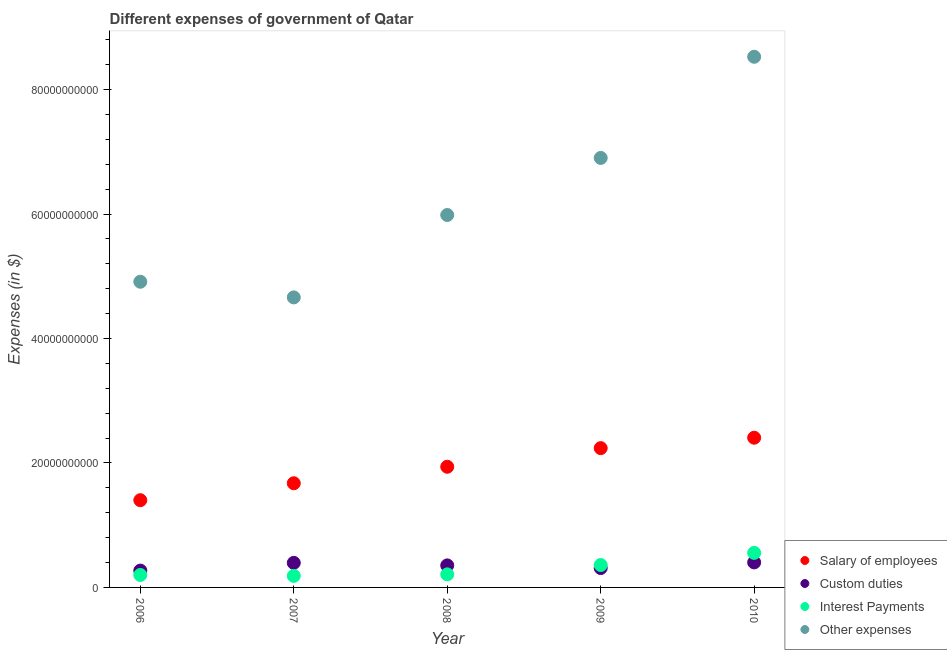How many different coloured dotlines are there?
Make the answer very short. 4. Is the number of dotlines equal to the number of legend labels?
Your answer should be very brief. Yes. What is the amount spent on salary of employees in 2006?
Your answer should be compact. 1.40e+1. Across all years, what is the maximum amount spent on other expenses?
Ensure brevity in your answer.  8.53e+1. Across all years, what is the minimum amount spent on custom duties?
Make the answer very short. 2.70e+09. What is the total amount spent on custom duties in the graph?
Give a very brief answer. 1.73e+1. What is the difference between the amount spent on interest payments in 2006 and that in 2008?
Your response must be concise. -9.39e+07. What is the difference between the amount spent on interest payments in 2010 and the amount spent on custom duties in 2008?
Your answer should be compact. 2.01e+09. What is the average amount spent on custom duties per year?
Give a very brief answer. 3.46e+09. In the year 2007, what is the difference between the amount spent on other expenses and amount spent on salary of employees?
Provide a short and direct response. 2.99e+1. What is the ratio of the amount spent on custom duties in 2006 to that in 2010?
Provide a short and direct response. 0.67. Is the amount spent on other expenses in 2006 less than that in 2009?
Ensure brevity in your answer.  Yes. Is the difference between the amount spent on salary of employees in 2007 and 2010 greater than the difference between the amount spent on interest payments in 2007 and 2010?
Provide a succinct answer. No. What is the difference between the highest and the second highest amount spent on other expenses?
Provide a succinct answer. 1.63e+1. What is the difference between the highest and the lowest amount spent on interest payments?
Offer a terse response. 3.69e+09. In how many years, is the amount spent on other expenses greater than the average amount spent on other expenses taken over all years?
Your answer should be very brief. 2. Is the sum of the amount spent on interest payments in 2008 and 2010 greater than the maximum amount spent on custom duties across all years?
Ensure brevity in your answer.  Yes. Is it the case that in every year, the sum of the amount spent on other expenses and amount spent on interest payments is greater than the sum of amount spent on salary of employees and amount spent on custom duties?
Offer a very short reply. Yes. Does the amount spent on other expenses monotonically increase over the years?
Provide a succinct answer. No. Is the amount spent on salary of employees strictly greater than the amount spent on other expenses over the years?
Make the answer very short. No. Is the amount spent on salary of employees strictly less than the amount spent on interest payments over the years?
Make the answer very short. No. How many years are there in the graph?
Offer a very short reply. 5. What is the difference between two consecutive major ticks on the Y-axis?
Provide a short and direct response. 2.00e+1. Are the values on the major ticks of Y-axis written in scientific E-notation?
Make the answer very short. No. Does the graph contain any zero values?
Offer a terse response. No. Where does the legend appear in the graph?
Provide a short and direct response. Bottom right. How many legend labels are there?
Offer a very short reply. 4. What is the title of the graph?
Provide a succinct answer. Different expenses of government of Qatar. What is the label or title of the X-axis?
Make the answer very short. Year. What is the label or title of the Y-axis?
Keep it short and to the point. Expenses (in $). What is the Expenses (in $) of Salary of employees in 2006?
Your answer should be compact. 1.40e+1. What is the Expenses (in $) in Custom duties in 2006?
Make the answer very short. 2.70e+09. What is the Expenses (in $) in Interest Payments in 2006?
Your answer should be very brief. 2.01e+09. What is the Expenses (in $) of Other expenses in 2006?
Offer a very short reply. 4.91e+1. What is the Expenses (in $) of Salary of employees in 2007?
Ensure brevity in your answer.  1.67e+1. What is the Expenses (in $) of Custom duties in 2007?
Provide a short and direct response. 3.95e+09. What is the Expenses (in $) in Interest Payments in 2007?
Offer a very short reply. 1.86e+09. What is the Expenses (in $) in Other expenses in 2007?
Make the answer very short. 4.66e+1. What is the Expenses (in $) in Salary of employees in 2008?
Ensure brevity in your answer.  1.94e+1. What is the Expenses (in $) of Custom duties in 2008?
Provide a short and direct response. 3.54e+09. What is the Expenses (in $) of Interest Payments in 2008?
Your response must be concise. 2.10e+09. What is the Expenses (in $) of Other expenses in 2008?
Give a very brief answer. 5.98e+1. What is the Expenses (in $) in Salary of employees in 2009?
Your response must be concise. 2.24e+1. What is the Expenses (in $) in Custom duties in 2009?
Offer a very short reply. 3.11e+09. What is the Expenses (in $) of Interest Payments in 2009?
Provide a succinct answer. 3.60e+09. What is the Expenses (in $) of Other expenses in 2009?
Keep it short and to the point. 6.90e+1. What is the Expenses (in $) in Salary of employees in 2010?
Provide a succinct answer. 2.41e+1. What is the Expenses (in $) of Custom duties in 2010?
Ensure brevity in your answer.  4.02e+09. What is the Expenses (in $) in Interest Payments in 2010?
Offer a very short reply. 5.55e+09. What is the Expenses (in $) in Other expenses in 2010?
Give a very brief answer. 8.53e+1. Across all years, what is the maximum Expenses (in $) of Salary of employees?
Give a very brief answer. 2.41e+1. Across all years, what is the maximum Expenses (in $) in Custom duties?
Give a very brief answer. 4.02e+09. Across all years, what is the maximum Expenses (in $) in Interest Payments?
Provide a succinct answer. 5.55e+09. Across all years, what is the maximum Expenses (in $) in Other expenses?
Your answer should be very brief. 8.53e+1. Across all years, what is the minimum Expenses (in $) in Salary of employees?
Ensure brevity in your answer.  1.40e+1. Across all years, what is the minimum Expenses (in $) in Custom duties?
Your answer should be compact. 2.70e+09. Across all years, what is the minimum Expenses (in $) of Interest Payments?
Keep it short and to the point. 1.86e+09. Across all years, what is the minimum Expenses (in $) of Other expenses?
Provide a succinct answer. 4.66e+1. What is the total Expenses (in $) of Salary of employees in the graph?
Offer a terse response. 9.66e+1. What is the total Expenses (in $) in Custom duties in the graph?
Offer a very short reply. 1.73e+1. What is the total Expenses (in $) of Interest Payments in the graph?
Your answer should be compact. 1.51e+1. What is the total Expenses (in $) in Other expenses in the graph?
Give a very brief answer. 3.10e+11. What is the difference between the Expenses (in $) in Salary of employees in 2006 and that in 2007?
Offer a very short reply. -2.72e+09. What is the difference between the Expenses (in $) of Custom duties in 2006 and that in 2007?
Offer a very short reply. -1.24e+09. What is the difference between the Expenses (in $) of Interest Payments in 2006 and that in 2007?
Your answer should be very brief. 1.51e+08. What is the difference between the Expenses (in $) in Other expenses in 2006 and that in 2007?
Ensure brevity in your answer.  2.51e+09. What is the difference between the Expenses (in $) in Salary of employees in 2006 and that in 2008?
Make the answer very short. -5.37e+09. What is the difference between the Expenses (in $) of Custom duties in 2006 and that in 2008?
Keep it short and to the point. -8.38e+08. What is the difference between the Expenses (in $) of Interest Payments in 2006 and that in 2008?
Give a very brief answer. -9.39e+07. What is the difference between the Expenses (in $) of Other expenses in 2006 and that in 2008?
Your response must be concise. -1.07e+1. What is the difference between the Expenses (in $) of Salary of employees in 2006 and that in 2009?
Provide a succinct answer. -8.36e+09. What is the difference between the Expenses (in $) of Custom duties in 2006 and that in 2009?
Offer a very short reply. -4.11e+08. What is the difference between the Expenses (in $) in Interest Payments in 2006 and that in 2009?
Provide a succinct answer. -1.59e+09. What is the difference between the Expenses (in $) in Other expenses in 2006 and that in 2009?
Make the answer very short. -1.99e+1. What is the difference between the Expenses (in $) in Salary of employees in 2006 and that in 2010?
Keep it short and to the point. -1.00e+1. What is the difference between the Expenses (in $) of Custom duties in 2006 and that in 2010?
Provide a short and direct response. -1.32e+09. What is the difference between the Expenses (in $) in Interest Payments in 2006 and that in 2010?
Offer a terse response. -3.54e+09. What is the difference between the Expenses (in $) in Other expenses in 2006 and that in 2010?
Your answer should be very brief. -3.62e+1. What is the difference between the Expenses (in $) of Salary of employees in 2007 and that in 2008?
Your answer should be compact. -2.65e+09. What is the difference between the Expenses (in $) in Custom duties in 2007 and that in 2008?
Ensure brevity in your answer.  4.05e+08. What is the difference between the Expenses (in $) in Interest Payments in 2007 and that in 2008?
Your answer should be very brief. -2.45e+08. What is the difference between the Expenses (in $) in Other expenses in 2007 and that in 2008?
Make the answer very short. -1.32e+1. What is the difference between the Expenses (in $) in Salary of employees in 2007 and that in 2009?
Provide a short and direct response. -5.64e+09. What is the difference between the Expenses (in $) in Custom duties in 2007 and that in 2009?
Give a very brief answer. 8.32e+08. What is the difference between the Expenses (in $) in Interest Payments in 2007 and that in 2009?
Keep it short and to the point. -1.74e+09. What is the difference between the Expenses (in $) in Other expenses in 2007 and that in 2009?
Provide a succinct answer. -2.24e+1. What is the difference between the Expenses (in $) in Salary of employees in 2007 and that in 2010?
Give a very brief answer. -7.32e+09. What is the difference between the Expenses (in $) in Custom duties in 2007 and that in 2010?
Offer a terse response. -7.32e+07. What is the difference between the Expenses (in $) of Interest Payments in 2007 and that in 2010?
Provide a short and direct response. -3.69e+09. What is the difference between the Expenses (in $) in Other expenses in 2007 and that in 2010?
Give a very brief answer. -3.87e+1. What is the difference between the Expenses (in $) in Salary of employees in 2008 and that in 2009?
Give a very brief answer. -2.99e+09. What is the difference between the Expenses (in $) of Custom duties in 2008 and that in 2009?
Offer a terse response. 4.27e+08. What is the difference between the Expenses (in $) of Interest Payments in 2008 and that in 2009?
Ensure brevity in your answer.  -1.50e+09. What is the difference between the Expenses (in $) of Other expenses in 2008 and that in 2009?
Provide a short and direct response. -9.17e+09. What is the difference between the Expenses (in $) of Salary of employees in 2008 and that in 2010?
Give a very brief answer. -4.67e+09. What is the difference between the Expenses (in $) in Custom duties in 2008 and that in 2010?
Make the answer very short. -4.78e+08. What is the difference between the Expenses (in $) in Interest Payments in 2008 and that in 2010?
Your response must be concise. -3.45e+09. What is the difference between the Expenses (in $) of Other expenses in 2008 and that in 2010?
Offer a very short reply. -2.54e+1. What is the difference between the Expenses (in $) in Salary of employees in 2009 and that in 2010?
Your response must be concise. -1.67e+09. What is the difference between the Expenses (in $) in Custom duties in 2009 and that in 2010?
Offer a very short reply. -9.05e+08. What is the difference between the Expenses (in $) of Interest Payments in 2009 and that in 2010?
Provide a succinct answer. -1.95e+09. What is the difference between the Expenses (in $) of Other expenses in 2009 and that in 2010?
Ensure brevity in your answer.  -1.63e+1. What is the difference between the Expenses (in $) of Salary of employees in 2006 and the Expenses (in $) of Custom duties in 2007?
Offer a terse response. 1.01e+1. What is the difference between the Expenses (in $) of Salary of employees in 2006 and the Expenses (in $) of Interest Payments in 2007?
Your answer should be compact. 1.22e+1. What is the difference between the Expenses (in $) of Salary of employees in 2006 and the Expenses (in $) of Other expenses in 2007?
Your response must be concise. -3.26e+1. What is the difference between the Expenses (in $) of Custom duties in 2006 and the Expenses (in $) of Interest Payments in 2007?
Offer a very short reply. 8.48e+08. What is the difference between the Expenses (in $) of Custom duties in 2006 and the Expenses (in $) of Other expenses in 2007?
Your answer should be compact. -4.39e+1. What is the difference between the Expenses (in $) of Interest Payments in 2006 and the Expenses (in $) of Other expenses in 2007?
Ensure brevity in your answer.  -4.46e+1. What is the difference between the Expenses (in $) in Salary of employees in 2006 and the Expenses (in $) in Custom duties in 2008?
Provide a short and direct response. 1.05e+1. What is the difference between the Expenses (in $) in Salary of employees in 2006 and the Expenses (in $) in Interest Payments in 2008?
Your response must be concise. 1.19e+1. What is the difference between the Expenses (in $) of Salary of employees in 2006 and the Expenses (in $) of Other expenses in 2008?
Keep it short and to the point. -4.58e+1. What is the difference between the Expenses (in $) in Custom duties in 2006 and the Expenses (in $) in Interest Payments in 2008?
Provide a succinct answer. 6.03e+08. What is the difference between the Expenses (in $) in Custom duties in 2006 and the Expenses (in $) in Other expenses in 2008?
Your answer should be compact. -5.71e+1. What is the difference between the Expenses (in $) in Interest Payments in 2006 and the Expenses (in $) in Other expenses in 2008?
Make the answer very short. -5.78e+1. What is the difference between the Expenses (in $) in Salary of employees in 2006 and the Expenses (in $) in Custom duties in 2009?
Keep it short and to the point. 1.09e+1. What is the difference between the Expenses (in $) of Salary of employees in 2006 and the Expenses (in $) of Interest Payments in 2009?
Offer a very short reply. 1.04e+1. What is the difference between the Expenses (in $) in Salary of employees in 2006 and the Expenses (in $) in Other expenses in 2009?
Provide a short and direct response. -5.50e+1. What is the difference between the Expenses (in $) in Custom duties in 2006 and the Expenses (in $) in Interest Payments in 2009?
Keep it short and to the point. -8.96e+08. What is the difference between the Expenses (in $) in Custom duties in 2006 and the Expenses (in $) in Other expenses in 2009?
Provide a succinct answer. -6.63e+1. What is the difference between the Expenses (in $) in Interest Payments in 2006 and the Expenses (in $) in Other expenses in 2009?
Provide a succinct answer. -6.70e+1. What is the difference between the Expenses (in $) in Salary of employees in 2006 and the Expenses (in $) in Custom duties in 2010?
Offer a terse response. 1.00e+1. What is the difference between the Expenses (in $) in Salary of employees in 2006 and the Expenses (in $) in Interest Payments in 2010?
Make the answer very short. 8.47e+09. What is the difference between the Expenses (in $) in Salary of employees in 2006 and the Expenses (in $) in Other expenses in 2010?
Your answer should be very brief. -7.13e+1. What is the difference between the Expenses (in $) of Custom duties in 2006 and the Expenses (in $) of Interest Payments in 2010?
Offer a terse response. -2.84e+09. What is the difference between the Expenses (in $) of Custom duties in 2006 and the Expenses (in $) of Other expenses in 2010?
Offer a very short reply. -8.26e+1. What is the difference between the Expenses (in $) in Interest Payments in 2006 and the Expenses (in $) in Other expenses in 2010?
Your answer should be very brief. -8.33e+1. What is the difference between the Expenses (in $) of Salary of employees in 2007 and the Expenses (in $) of Custom duties in 2008?
Offer a very short reply. 1.32e+1. What is the difference between the Expenses (in $) of Salary of employees in 2007 and the Expenses (in $) of Interest Payments in 2008?
Provide a succinct answer. 1.46e+1. What is the difference between the Expenses (in $) of Salary of employees in 2007 and the Expenses (in $) of Other expenses in 2008?
Make the answer very short. -4.31e+1. What is the difference between the Expenses (in $) in Custom duties in 2007 and the Expenses (in $) in Interest Payments in 2008?
Ensure brevity in your answer.  1.85e+09. What is the difference between the Expenses (in $) in Custom duties in 2007 and the Expenses (in $) in Other expenses in 2008?
Provide a short and direct response. -5.59e+1. What is the difference between the Expenses (in $) of Interest Payments in 2007 and the Expenses (in $) of Other expenses in 2008?
Provide a succinct answer. -5.80e+1. What is the difference between the Expenses (in $) of Salary of employees in 2007 and the Expenses (in $) of Custom duties in 2009?
Provide a short and direct response. 1.36e+1. What is the difference between the Expenses (in $) of Salary of employees in 2007 and the Expenses (in $) of Interest Payments in 2009?
Make the answer very short. 1.31e+1. What is the difference between the Expenses (in $) of Salary of employees in 2007 and the Expenses (in $) of Other expenses in 2009?
Your answer should be very brief. -5.23e+1. What is the difference between the Expenses (in $) of Custom duties in 2007 and the Expenses (in $) of Interest Payments in 2009?
Make the answer very short. 3.47e+08. What is the difference between the Expenses (in $) of Custom duties in 2007 and the Expenses (in $) of Other expenses in 2009?
Keep it short and to the point. -6.51e+1. What is the difference between the Expenses (in $) in Interest Payments in 2007 and the Expenses (in $) in Other expenses in 2009?
Give a very brief answer. -6.72e+1. What is the difference between the Expenses (in $) in Salary of employees in 2007 and the Expenses (in $) in Custom duties in 2010?
Your answer should be compact. 1.27e+1. What is the difference between the Expenses (in $) in Salary of employees in 2007 and the Expenses (in $) in Interest Payments in 2010?
Your answer should be very brief. 1.12e+1. What is the difference between the Expenses (in $) of Salary of employees in 2007 and the Expenses (in $) of Other expenses in 2010?
Offer a terse response. -6.85e+1. What is the difference between the Expenses (in $) in Custom duties in 2007 and the Expenses (in $) in Interest Payments in 2010?
Make the answer very short. -1.60e+09. What is the difference between the Expenses (in $) in Custom duties in 2007 and the Expenses (in $) in Other expenses in 2010?
Your response must be concise. -8.13e+1. What is the difference between the Expenses (in $) of Interest Payments in 2007 and the Expenses (in $) of Other expenses in 2010?
Your answer should be very brief. -8.34e+1. What is the difference between the Expenses (in $) of Salary of employees in 2008 and the Expenses (in $) of Custom duties in 2009?
Ensure brevity in your answer.  1.63e+1. What is the difference between the Expenses (in $) in Salary of employees in 2008 and the Expenses (in $) in Interest Payments in 2009?
Ensure brevity in your answer.  1.58e+1. What is the difference between the Expenses (in $) in Salary of employees in 2008 and the Expenses (in $) in Other expenses in 2009?
Keep it short and to the point. -4.96e+1. What is the difference between the Expenses (in $) of Custom duties in 2008 and the Expenses (in $) of Interest Payments in 2009?
Offer a terse response. -5.82e+07. What is the difference between the Expenses (in $) of Custom duties in 2008 and the Expenses (in $) of Other expenses in 2009?
Your answer should be very brief. -6.55e+1. What is the difference between the Expenses (in $) of Interest Payments in 2008 and the Expenses (in $) of Other expenses in 2009?
Your answer should be compact. -6.69e+1. What is the difference between the Expenses (in $) in Salary of employees in 2008 and the Expenses (in $) in Custom duties in 2010?
Your answer should be very brief. 1.54e+1. What is the difference between the Expenses (in $) in Salary of employees in 2008 and the Expenses (in $) in Interest Payments in 2010?
Keep it short and to the point. 1.38e+1. What is the difference between the Expenses (in $) of Salary of employees in 2008 and the Expenses (in $) of Other expenses in 2010?
Keep it short and to the point. -6.59e+1. What is the difference between the Expenses (in $) in Custom duties in 2008 and the Expenses (in $) in Interest Payments in 2010?
Your answer should be very brief. -2.01e+09. What is the difference between the Expenses (in $) of Custom duties in 2008 and the Expenses (in $) of Other expenses in 2010?
Offer a terse response. -8.17e+1. What is the difference between the Expenses (in $) of Interest Payments in 2008 and the Expenses (in $) of Other expenses in 2010?
Your answer should be very brief. -8.32e+1. What is the difference between the Expenses (in $) in Salary of employees in 2009 and the Expenses (in $) in Custom duties in 2010?
Your response must be concise. 1.84e+1. What is the difference between the Expenses (in $) in Salary of employees in 2009 and the Expenses (in $) in Interest Payments in 2010?
Ensure brevity in your answer.  1.68e+1. What is the difference between the Expenses (in $) of Salary of employees in 2009 and the Expenses (in $) of Other expenses in 2010?
Ensure brevity in your answer.  -6.29e+1. What is the difference between the Expenses (in $) in Custom duties in 2009 and the Expenses (in $) in Interest Payments in 2010?
Give a very brief answer. -2.43e+09. What is the difference between the Expenses (in $) in Custom duties in 2009 and the Expenses (in $) in Other expenses in 2010?
Your response must be concise. -8.22e+1. What is the difference between the Expenses (in $) of Interest Payments in 2009 and the Expenses (in $) of Other expenses in 2010?
Your response must be concise. -8.17e+1. What is the average Expenses (in $) in Salary of employees per year?
Ensure brevity in your answer.  1.93e+1. What is the average Expenses (in $) in Custom duties per year?
Offer a terse response. 3.46e+09. What is the average Expenses (in $) of Interest Payments per year?
Offer a terse response. 3.02e+09. What is the average Expenses (in $) of Other expenses per year?
Make the answer very short. 6.20e+1. In the year 2006, what is the difference between the Expenses (in $) in Salary of employees and Expenses (in $) in Custom duties?
Make the answer very short. 1.13e+1. In the year 2006, what is the difference between the Expenses (in $) of Salary of employees and Expenses (in $) of Interest Payments?
Offer a very short reply. 1.20e+1. In the year 2006, what is the difference between the Expenses (in $) of Salary of employees and Expenses (in $) of Other expenses?
Provide a succinct answer. -3.51e+1. In the year 2006, what is the difference between the Expenses (in $) in Custom duties and Expenses (in $) in Interest Payments?
Keep it short and to the point. 6.97e+08. In the year 2006, what is the difference between the Expenses (in $) of Custom duties and Expenses (in $) of Other expenses?
Provide a succinct answer. -4.64e+1. In the year 2006, what is the difference between the Expenses (in $) in Interest Payments and Expenses (in $) in Other expenses?
Offer a terse response. -4.71e+1. In the year 2007, what is the difference between the Expenses (in $) of Salary of employees and Expenses (in $) of Custom duties?
Provide a succinct answer. 1.28e+1. In the year 2007, what is the difference between the Expenses (in $) in Salary of employees and Expenses (in $) in Interest Payments?
Ensure brevity in your answer.  1.49e+1. In the year 2007, what is the difference between the Expenses (in $) of Salary of employees and Expenses (in $) of Other expenses?
Make the answer very short. -2.99e+1. In the year 2007, what is the difference between the Expenses (in $) of Custom duties and Expenses (in $) of Interest Payments?
Provide a succinct answer. 2.09e+09. In the year 2007, what is the difference between the Expenses (in $) in Custom duties and Expenses (in $) in Other expenses?
Your answer should be compact. -4.27e+1. In the year 2007, what is the difference between the Expenses (in $) in Interest Payments and Expenses (in $) in Other expenses?
Provide a succinct answer. -4.48e+1. In the year 2008, what is the difference between the Expenses (in $) of Salary of employees and Expenses (in $) of Custom duties?
Make the answer very short. 1.58e+1. In the year 2008, what is the difference between the Expenses (in $) in Salary of employees and Expenses (in $) in Interest Payments?
Ensure brevity in your answer.  1.73e+1. In the year 2008, what is the difference between the Expenses (in $) in Salary of employees and Expenses (in $) in Other expenses?
Your response must be concise. -4.05e+1. In the year 2008, what is the difference between the Expenses (in $) in Custom duties and Expenses (in $) in Interest Payments?
Your answer should be very brief. 1.44e+09. In the year 2008, what is the difference between the Expenses (in $) in Custom duties and Expenses (in $) in Other expenses?
Your answer should be compact. -5.63e+1. In the year 2008, what is the difference between the Expenses (in $) in Interest Payments and Expenses (in $) in Other expenses?
Ensure brevity in your answer.  -5.77e+1. In the year 2009, what is the difference between the Expenses (in $) in Salary of employees and Expenses (in $) in Custom duties?
Provide a succinct answer. 1.93e+1. In the year 2009, what is the difference between the Expenses (in $) of Salary of employees and Expenses (in $) of Interest Payments?
Your response must be concise. 1.88e+1. In the year 2009, what is the difference between the Expenses (in $) of Salary of employees and Expenses (in $) of Other expenses?
Give a very brief answer. -4.66e+1. In the year 2009, what is the difference between the Expenses (in $) in Custom duties and Expenses (in $) in Interest Payments?
Provide a short and direct response. -4.85e+08. In the year 2009, what is the difference between the Expenses (in $) in Custom duties and Expenses (in $) in Other expenses?
Ensure brevity in your answer.  -6.59e+1. In the year 2009, what is the difference between the Expenses (in $) of Interest Payments and Expenses (in $) of Other expenses?
Give a very brief answer. -6.54e+1. In the year 2010, what is the difference between the Expenses (in $) in Salary of employees and Expenses (in $) in Custom duties?
Ensure brevity in your answer.  2.00e+1. In the year 2010, what is the difference between the Expenses (in $) in Salary of employees and Expenses (in $) in Interest Payments?
Keep it short and to the point. 1.85e+1. In the year 2010, what is the difference between the Expenses (in $) in Salary of employees and Expenses (in $) in Other expenses?
Offer a very short reply. -6.12e+1. In the year 2010, what is the difference between the Expenses (in $) in Custom duties and Expenses (in $) in Interest Payments?
Offer a terse response. -1.53e+09. In the year 2010, what is the difference between the Expenses (in $) of Custom duties and Expenses (in $) of Other expenses?
Ensure brevity in your answer.  -8.13e+1. In the year 2010, what is the difference between the Expenses (in $) in Interest Payments and Expenses (in $) in Other expenses?
Ensure brevity in your answer.  -7.97e+1. What is the ratio of the Expenses (in $) of Salary of employees in 2006 to that in 2007?
Give a very brief answer. 0.84. What is the ratio of the Expenses (in $) of Custom duties in 2006 to that in 2007?
Keep it short and to the point. 0.69. What is the ratio of the Expenses (in $) in Interest Payments in 2006 to that in 2007?
Keep it short and to the point. 1.08. What is the ratio of the Expenses (in $) in Other expenses in 2006 to that in 2007?
Give a very brief answer. 1.05. What is the ratio of the Expenses (in $) of Salary of employees in 2006 to that in 2008?
Offer a terse response. 0.72. What is the ratio of the Expenses (in $) in Custom duties in 2006 to that in 2008?
Make the answer very short. 0.76. What is the ratio of the Expenses (in $) in Interest Payments in 2006 to that in 2008?
Your answer should be compact. 0.96. What is the ratio of the Expenses (in $) of Other expenses in 2006 to that in 2008?
Offer a very short reply. 0.82. What is the ratio of the Expenses (in $) of Salary of employees in 2006 to that in 2009?
Offer a terse response. 0.63. What is the ratio of the Expenses (in $) of Custom duties in 2006 to that in 2009?
Make the answer very short. 0.87. What is the ratio of the Expenses (in $) in Interest Payments in 2006 to that in 2009?
Make the answer very short. 0.56. What is the ratio of the Expenses (in $) in Other expenses in 2006 to that in 2009?
Your response must be concise. 0.71. What is the ratio of the Expenses (in $) of Salary of employees in 2006 to that in 2010?
Ensure brevity in your answer.  0.58. What is the ratio of the Expenses (in $) of Custom duties in 2006 to that in 2010?
Offer a very short reply. 0.67. What is the ratio of the Expenses (in $) of Interest Payments in 2006 to that in 2010?
Your response must be concise. 0.36. What is the ratio of the Expenses (in $) in Other expenses in 2006 to that in 2010?
Offer a very short reply. 0.58. What is the ratio of the Expenses (in $) in Salary of employees in 2007 to that in 2008?
Ensure brevity in your answer.  0.86. What is the ratio of the Expenses (in $) in Custom duties in 2007 to that in 2008?
Provide a succinct answer. 1.11. What is the ratio of the Expenses (in $) in Interest Payments in 2007 to that in 2008?
Ensure brevity in your answer.  0.88. What is the ratio of the Expenses (in $) in Other expenses in 2007 to that in 2008?
Your answer should be very brief. 0.78. What is the ratio of the Expenses (in $) in Salary of employees in 2007 to that in 2009?
Your response must be concise. 0.75. What is the ratio of the Expenses (in $) in Custom duties in 2007 to that in 2009?
Your answer should be compact. 1.27. What is the ratio of the Expenses (in $) of Interest Payments in 2007 to that in 2009?
Give a very brief answer. 0.52. What is the ratio of the Expenses (in $) in Other expenses in 2007 to that in 2009?
Offer a terse response. 0.68. What is the ratio of the Expenses (in $) of Salary of employees in 2007 to that in 2010?
Give a very brief answer. 0.7. What is the ratio of the Expenses (in $) in Custom duties in 2007 to that in 2010?
Give a very brief answer. 0.98. What is the ratio of the Expenses (in $) in Interest Payments in 2007 to that in 2010?
Your answer should be very brief. 0.33. What is the ratio of the Expenses (in $) of Other expenses in 2007 to that in 2010?
Your answer should be compact. 0.55. What is the ratio of the Expenses (in $) in Salary of employees in 2008 to that in 2009?
Ensure brevity in your answer.  0.87. What is the ratio of the Expenses (in $) of Custom duties in 2008 to that in 2009?
Your answer should be compact. 1.14. What is the ratio of the Expenses (in $) in Interest Payments in 2008 to that in 2009?
Provide a succinct answer. 0.58. What is the ratio of the Expenses (in $) in Other expenses in 2008 to that in 2009?
Offer a terse response. 0.87. What is the ratio of the Expenses (in $) in Salary of employees in 2008 to that in 2010?
Offer a terse response. 0.81. What is the ratio of the Expenses (in $) in Custom duties in 2008 to that in 2010?
Offer a terse response. 0.88. What is the ratio of the Expenses (in $) of Interest Payments in 2008 to that in 2010?
Your response must be concise. 0.38. What is the ratio of the Expenses (in $) of Other expenses in 2008 to that in 2010?
Your answer should be very brief. 0.7. What is the ratio of the Expenses (in $) in Salary of employees in 2009 to that in 2010?
Provide a short and direct response. 0.93. What is the ratio of the Expenses (in $) of Custom duties in 2009 to that in 2010?
Make the answer very short. 0.77. What is the ratio of the Expenses (in $) in Interest Payments in 2009 to that in 2010?
Offer a very short reply. 0.65. What is the ratio of the Expenses (in $) in Other expenses in 2009 to that in 2010?
Provide a succinct answer. 0.81. What is the difference between the highest and the second highest Expenses (in $) of Salary of employees?
Offer a terse response. 1.67e+09. What is the difference between the highest and the second highest Expenses (in $) in Custom duties?
Provide a succinct answer. 7.32e+07. What is the difference between the highest and the second highest Expenses (in $) in Interest Payments?
Give a very brief answer. 1.95e+09. What is the difference between the highest and the second highest Expenses (in $) in Other expenses?
Offer a terse response. 1.63e+1. What is the difference between the highest and the lowest Expenses (in $) in Salary of employees?
Ensure brevity in your answer.  1.00e+1. What is the difference between the highest and the lowest Expenses (in $) of Custom duties?
Provide a succinct answer. 1.32e+09. What is the difference between the highest and the lowest Expenses (in $) of Interest Payments?
Offer a very short reply. 3.69e+09. What is the difference between the highest and the lowest Expenses (in $) in Other expenses?
Provide a succinct answer. 3.87e+1. 